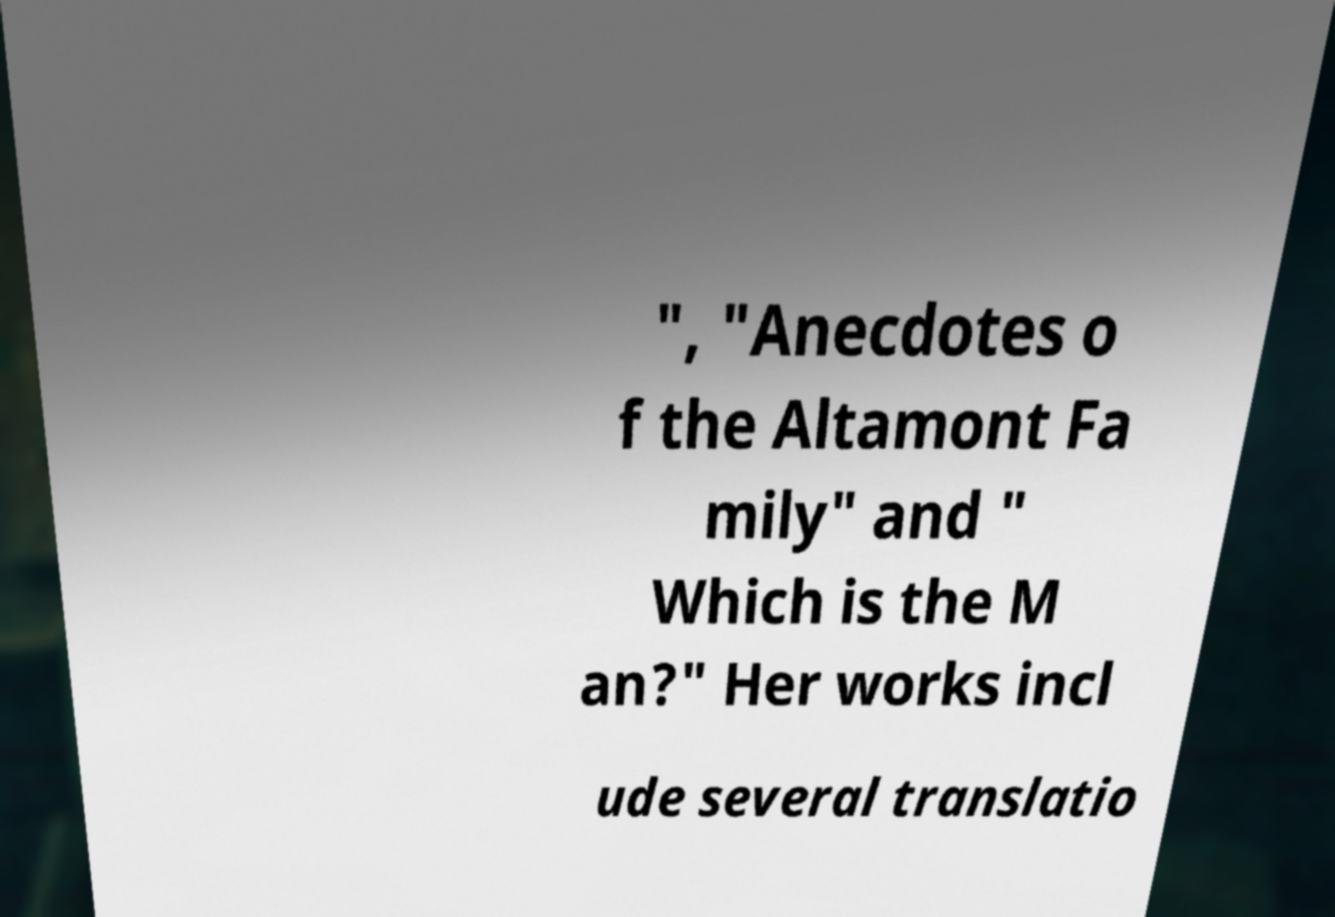Please read and relay the text visible in this image. What does it say? ", "Anecdotes o f the Altamont Fa mily" and " Which is the M an?" Her works incl ude several translatio 